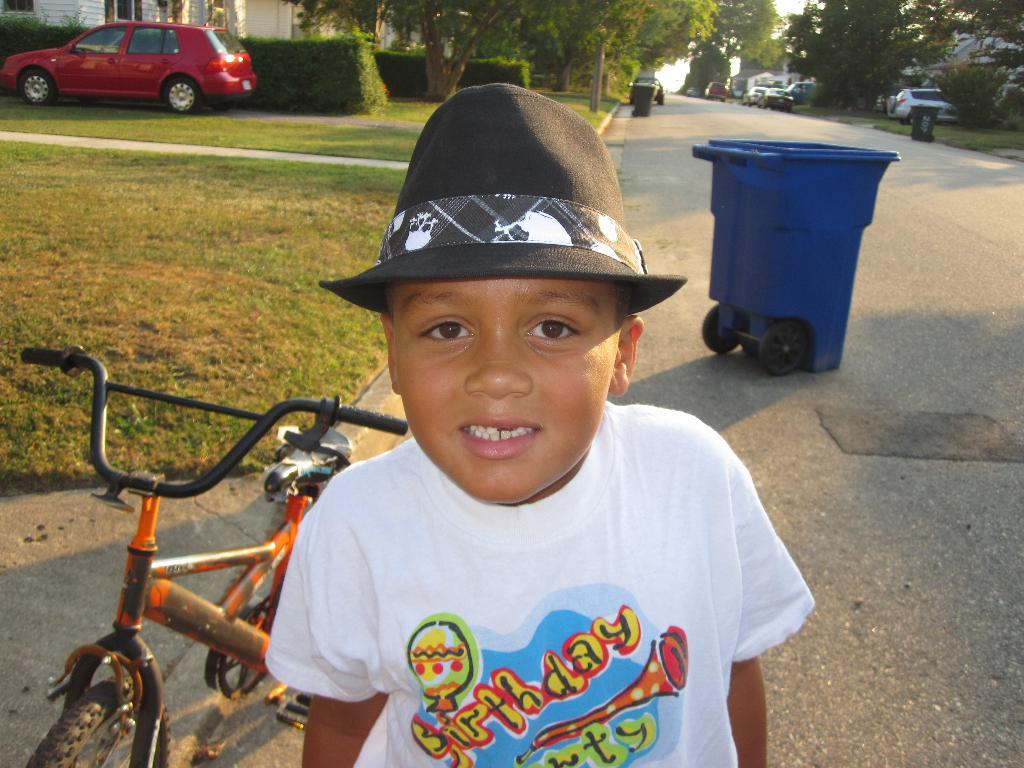What is the main subject in the foreground of the image? There is a child in the foreground of the image. What is the child wearing on their head? The child is wearing a black hat. Can you describe any other objects or features in the image? There is a dustbin on the right side of the image. How many snails can be seen crawling on the child's hat in the image? There are no snails present in the image, so it is not possible to determine their number or location. 